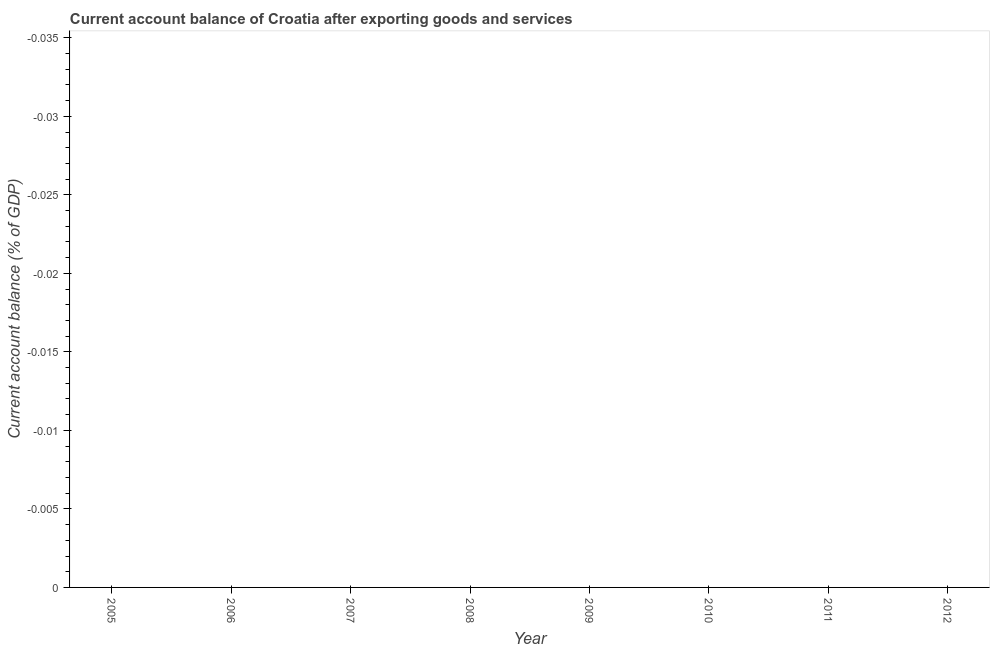What is the current account balance in 2008?
Your response must be concise. 0. What is the average current account balance per year?
Your answer should be compact. 0. In how many years, is the current account balance greater than the average current account balance taken over all years?
Offer a very short reply. 0. Does the current account balance monotonically increase over the years?
Your answer should be compact. No. What is the difference between two consecutive major ticks on the Y-axis?
Your answer should be compact. 0.01. Are the values on the major ticks of Y-axis written in scientific E-notation?
Provide a short and direct response. No. What is the title of the graph?
Your answer should be very brief. Current account balance of Croatia after exporting goods and services. What is the label or title of the Y-axis?
Offer a very short reply. Current account balance (% of GDP). What is the Current account balance (% of GDP) of 2005?
Keep it short and to the point. 0. What is the Current account balance (% of GDP) of 2007?
Give a very brief answer. 0. What is the Current account balance (% of GDP) of 2010?
Offer a terse response. 0. What is the Current account balance (% of GDP) in 2011?
Keep it short and to the point. 0. What is the Current account balance (% of GDP) in 2012?
Your response must be concise. 0. 